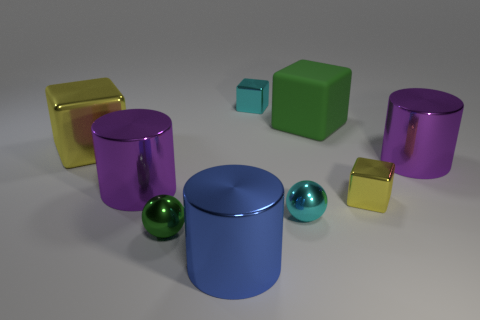How many tiny rubber objects are there?
Your answer should be compact. 0. There is a green thing that is behind the cyan shiny sphere; what size is it?
Your response must be concise. Large. Is the number of small green shiny balls that are in front of the blue metal cylinder the same as the number of large cyan metal spheres?
Ensure brevity in your answer.  Yes. Is there a cyan metallic object that has the same shape as the large matte thing?
Offer a terse response. Yes. There is a thing that is both behind the big yellow object and on the left side of the large green rubber object; what shape is it?
Provide a short and direct response. Cube. Is the big green block made of the same material as the purple cylinder left of the tiny green sphere?
Provide a short and direct response. No. Are there any small green objects in front of the big blue cylinder?
Your answer should be very brief. No. What number of things are either large blue metallic cylinders or purple objects that are right of the small green object?
Your answer should be compact. 2. What color is the metallic cylinder behind the purple metal cylinder that is to the left of the big green rubber thing?
Make the answer very short. Purple. What number of other objects are there of the same material as the small yellow block?
Ensure brevity in your answer.  7. 